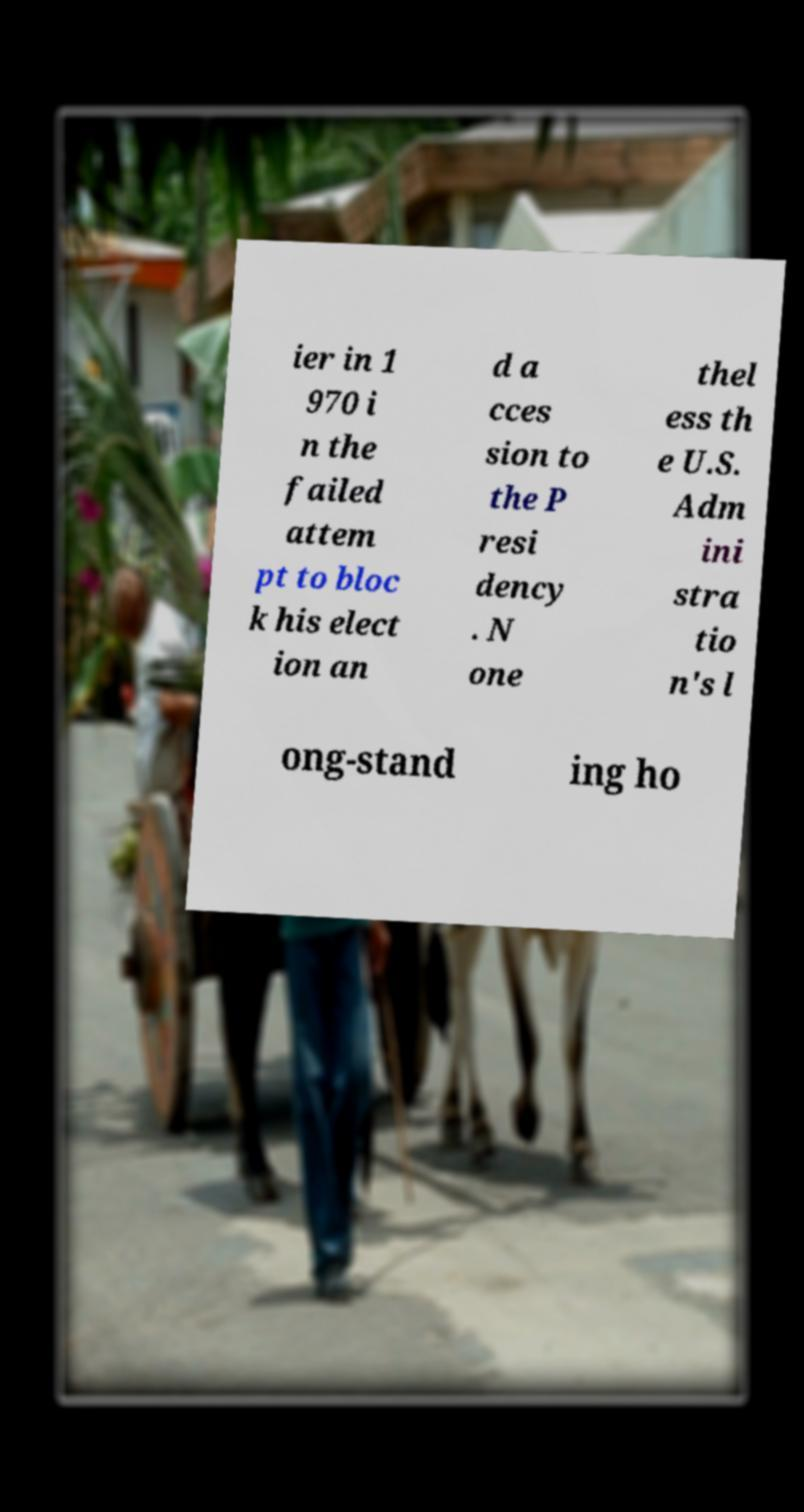I need the written content from this picture converted into text. Can you do that? ier in 1 970 i n the failed attem pt to bloc k his elect ion an d a cces sion to the P resi dency . N one thel ess th e U.S. Adm ini stra tio n's l ong-stand ing ho 